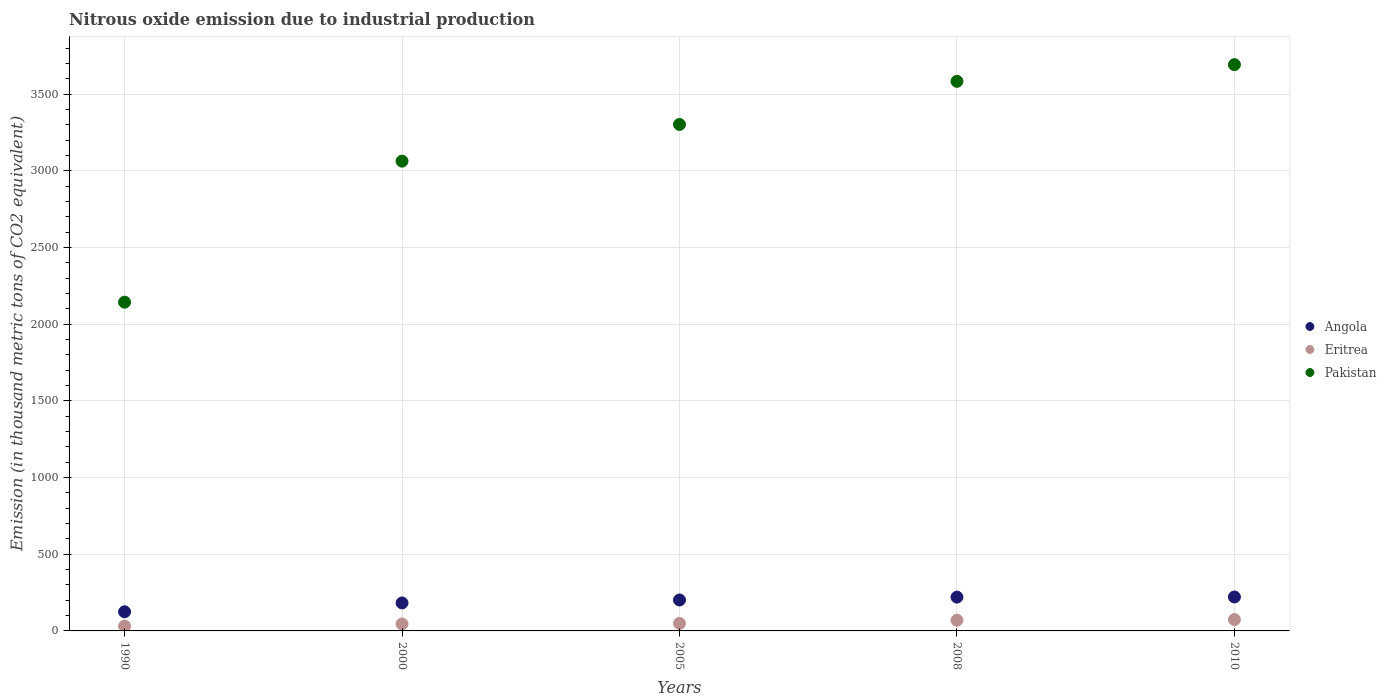What is the amount of nitrous oxide emitted in Angola in 2005?
Provide a short and direct response. 201.8. Across all years, what is the maximum amount of nitrous oxide emitted in Angola?
Provide a short and direct response. 221.4. Across all years, what is the minimum amount of nitrous oxide emitted in Eritrea?
Your answer should be very brief. 31.3. In which year was the amount of nitrous oxide emitted in Angola maximum?
Ensure brevity in your answer.  2010. In which year was the amount of nitrous oxide emitted in Pakistan minimum?
Your answer should be very brief. 1990. What is the total amount of nitrous oxide emitted in Eritrea in the graph?
Keep it short and to the point. 269.4. What is the difference between the amount of nitrous oxide emitted in Pakistan in 2000 and that in 2010?
Your answer should be very brief. -629.3. What is the difference between the amount of nitrous oxide emitted in Eritrea in 2005 and the amount of nitrous oxide emitted in Angola in 2010?
Ensure brevity in your answer.  -172.3. What is the average amount of nitrous oxide emitted in Pakistan per year?
Make the answer very short. 3157.4. In the year 2000, what is the difference between the amount of nitrous oxide emitted in Eritrea and amount of nitrous oxide emitted in Angola?
Your answer should be very brief. -137.1. In how many years, is the amount of nitrous oxide emitted in Pakistan greater than 2300 thousand metric tons?
Your answer should be very brief. 4. What is the ratio of the amount of nitrous oxide emitted in Eritrea in 1990 to that in 2008?
Provide a succinct answer. 0.45. Is the difference between the amount of nitrous oxide emitted in Eritrea in 1990 and 2008 greater than the difference between the amount of nitrous oxide emitted in Angola in 1990 and 2008?
Give a very brief answer. Yes. What is the difference between the highest and the second highest amount of nitrous oxide emitted in Pakistan?
Make the answer very short. 108.8. What is the difference between the highest and the lowest amount of nitrous oxide emitted in Eritrea?
Make the answer very short. 42.6. Is the sum of the amount of nitrous oxide emitted in Eritrea in 2000 and 2008 greater than the maximum amount of nitrous oxide emitted in Angola across all years?
Ensure brevity in your answer.  No. Is the amount of nitrous oxide emitted in Eritrea strictly greater than the amount of nitrous oxide emitted in Angola over the years?
Your answer should be compact. No. How many dotlines are there?
Your answer should be very brief. 3. Does the graph contain grids?
Keep it short and to the point. Yes. How many legend labels are there?
Your response must be concise. 3. How are the legend labels stacked?
Provide a short and direct response. Vertical. What is the title of the graph?
Offer a terse response. Nitrous oxide emission due to industrial production. What is the label or title of the Y-axis?
Provide a succinct answer. Emission (in thousand metric tons of CO2 equivalent). What is the Emission (in thousand metric tons of CO2 equivalent) in Angola in 1990?
Make the answer very short. 124.8. What is the Emission (in thousand metric tons of CO2 equivalent) in Eritrea in 1990?
Keep it short and to the point. 31.3. What is the Emission (in thousand metric tons of CO2 equivalent) in Pakistan in 1990?
Offer a terse response. 2143.8. What is the Emission (in thousand metric tons of CO2 equivalent) in Angola in 2000?
Ensure brevity in your answer.  182.5. What is the Emission (in thousand metric tons of CO2 equivalent) of Eritrea in 2000?
Keep it short and to the point. 45.4. What is the Emission (in thousand metric tons of CO2 equivalent) in Pakistan in 2000?
Your answer should be very brief. 3063.5. What is the Emission (in thousand metric tons of CO2 equivalent) in Angola in 2005?
Your answer should be compact. 201.8. What is the Emission (in thousand metric tons of CO2 equivalent) of Eritrea in 2005?
Give a very brief answer. 49.1. What is the Emission (in thousand metric tons of CO2 equivalent) in Pakistan in 2005?
Provide a succinct answer. 3302.9. What is the Emission (in thousand metric tons of CO2 equivalent) of Angola in 2008?
Keep it short and to the point. 220.4. What is the Emission (in thousand metric tons of CO2 equivalent) of Eritrea in 2008?
Provide a short and direct response. 69.7. What is the Emission (in thousand metric tons of CO2 equivalent) in Pakistan in 2008?
Your answer should be very brief. 3584. What is the Emission (in thousand metric tons of CO2 equivalent) of Angola in 2010?
Your answer should be very brief. 221.4. What is the Emission (in thousand metric tons of CO2 equivalent) in Eritrea in 2010?
Offer a very short reply. 73.9. What is the Emission (in thousand metric tons of CO2 equivalent) in Pakistan in 2010?
Provide a short and direct response. 3692.8. Across all years, what is the maximum Emission (in thousand metric tons of CO2 equivalent) in Angola?
Provide a short and direct response. 221.4. Across all years, what is the maximum Emission (in thousand metric tons of CO2 equivalent) of Eritrea?
Provide a short and direct response. 73.9. Across all years, what is the maximum Emission (in thousand metric tons of CO2 equivalent) of Pakistan?
Keep it short and to the point. 3692.8. Across all years, what is the minimum Emission (in thousand metric tons of CO2 equivalent) in Angola?
Give a very brief answer. 124.8. Across all years, what is the minimum Emission (in thousand metric tons of CO2 equivalent) in Eritrea?
Your answer should be compact. 31.3. Across all years, what is the minimum Emission (in thousand metric tons of CO2 equivalent) in Pakistan?
Ensure brevity in your answer.  2143.8. What is the total Emission (in thousand metric tons of CO2 equivalent) of Angola in the graph?
Your answer should be compact. 950.9. What is the total Emission (in thousand metric tons of CO2 equivalent) in Eritrea in the graph?
Keep it short and to the point. 269.4. What is the total Emission (in thousand metric tons of CO2 equivalent) of Pakistan in the graph?
Your answer should be very brief. 1.58e+04. What is the difference between the Emission (in thousand metric tons of CO2 equivalent) in Angola in 1990 and that in 2000?
Provide a succinct answer. -57.7. What is the difference between the Emission (in thousand metric tons of CO2 equivalent) of Eritrea in 1990 and that in 2000?
Give a very brief answer. -14.1. What is the difference between the Emission (in thousand metric tons of CO2 equivalent) in Pakistan in 1990 and that in 2000?
Provide a short and direct response. -919.7. What is the difference between the Emission (in thousand metric tons of CO2 equivalent) of Angola in 1990 and that in 2005?
Make the answer very short. -77. What is the difference between the Emission (in thousand metric tons of CO2 equivalent) of Eritrea in 1990 and that in 2005?
Offer a very short reply. -17.8. What is the difference between the Emission (in thousand metric tons of CO2 equivalent) in Pakistan in 1990 and that in 2005?
Make the answer very short. -1159.1. What is the difference between the Emission (in thousand metric tons of CO2 equivalent) in Angola in 1990 and that in 2008?
Provide a succinct answer. -95.6. What is the difference between the Emission (in thousand metric tons of CO2 equivalent) of Eritrea in 1990 and that in 2008?
Offer a terse response. -38.4. What is the difference between the Emission (in thousand metric tons of CO2 equivalent) of Pakistan in 1990 and that in 2008?
Your answer should be very brief. -1440.2. What is the difference between the Emission (in thousand metric tons of CO2 equivalent) in Angola in 1990 and that in 2010?
Your response must be concise. -96.6. What is the difference between the Emission (in thousand metric tons of CO2 equivalent) of Eritrea in 1990 and that in 2010?
Make the answer very short. -42.6. What is the difference between the Emission (in thousand metric tons of CO2 equivalent) of Pakistan in 1990 and that in 2010?
Make the answer very short. -1549. What is the difference between the Emission (in thousand metric tons of CO2 equivalent) of Angola in 2000 and that in 2005?
Make the answer very short. -19.3. What is the difference between the Emission (in thousand metric tons of CO2 equivalent) of Eritrea in 2000 and that in 2005?
Provide a short and direct response. -3.7. What is the difference between the Emission (in thousand metric tons of CO2 equivalent) of Pakistan in 2000 and that in 2005?
Keep it short and to the point. -239.4. What is the difference between the Emission (in thousand metric tons of CO2 equivalent) of Angola in 2000 and that in 2008?
Ensure brevity in your answer.  -37.9. What is the difference between the Emission (in thousand metric tons of CO2 equivalent) of Eritrea in 2000 and that in 2008?
Ensure brevity in your answer.  -24.3. What is the difference between the Emission (in thousand metric tons of CO2 equivalent) of Pakistan in 2000 and that in 2008?
Keep it short and to the point. -520.5. What is the difference between the Emission (in thousand metric tons of CO2 equivalent) in Angola in 2000 and that in 2010?
Your response must be concise. -38.9. What is the difference between the Emission (in thousand metric tons of CO2 equivalent) of Eritrea in 2000 and that in 2010?
Provide a short and direct response. -28.5. What is the difference between the Emission (in thousand metric tons of CO2 equivalent) in Pakistan in 2000 and that in 2010?
Make the answer very short. -629.3. What is the difference between the Emission (in thousand metric tons of CO2 equivalent) of Angola in 2005 and that in 2008?
Give a very brief answer. -18.6. What is the difference between the Emission (in thousand metric tons of CO2 equivalent) of Eritrea in 2005 and that in 2008?
Ensure brevity in your answer.  -20.6. What is the difference between the Emission (in thousand metric tons of CO2 equivalent) in Pakistan in 2005 and that in 2008?
Ensure brevity in your answer.  -281.1. What is the difference between the Emission (in thousand metric tons of CO2 equivalent) in Angola in 2005 and that in 2010?
Offer a terse response. -19.6. What is the difference between the Emission (in thousand metric tons of CO2 equivalent) of Eritrea in 2005 and that in 2010?
Offer a very short reply. -24.8. What is the difference between the Emission (in thousand metric tons of CO2 equivalent) of Pakistan in 2005 and that in 2010?
Offer a very short reply. -389.9. What is the difference between the Emission (in thousand metric tons of CO2 equivalent) in Pakistan in 2008 and that in 2010?
Your response must be concise. -108.8. What is the difference between the Emission (in thousand metric tons of CO2 equivalent) of Angola in 1990 and the Emission (in thousand metric tons of CO2 equivalent) of Eritrea in 2000?
Give a very brief answer. 79.4. What is the difference between the Emission (in thousand metric tons of CO2 equivalent) of Angola in 1990 and the Emission (in thousand metric tons of CO2 equivalent) of Pakistan in 2000?
Give a very brief answer. -2938.7. What is the difference between the Emission (in thousand metric tons of CO2 equivalent) in Eritrea in 1990 and the Emission (in thousand metric tons of CO2 equivalent) in Pakistan in 2000?
Give a very brief answer. -3032.2. What is the difference between the Emission (in thousand metric tons of CO2 equivalent) in Angola in 1990 and the Emission (in thousand metric tons of CO2 equivalent) in Eritrea in 2005?
Offer a very short reply. 75.7. What is the difference between the Emission (in thousand metric tons of CO2 equivalent) in Angola in 1990 and the Emission (in thousand metric tons of CO2 equivalent) in Pakistan in 2005?
Your response must be concise. -3178.1. What is the difference between the Emission (in thousand metric tons of CO2 equivalent) of Eritrea in 1990 and the Emission (in thousand metric tons of CO2 equivalent) of Pakistan in 2005?
Offer a terse response. -3271.6. What is the difference between the Emission (in thousand metric tons of CO2 equivalent) in Angola in 1990 and the Emission (in thousand metric tons of CO2 equivalent) in Eritrea in 2008?
Make the answer very short. 55.1. What is the difference between the Emission (in thousand metric tons of CO2 equivalent) of Angola in 1990 and the Emission (in thousand metric tons of CO2 equivalent) of Pakistan in 2008?
Keep it short and to the point. -3459.2. What is the difference between the Emission (in thousand metric tons of CO2 equivalent) of Eritrea in 1990 and the Emission (in thousand metric tons of CO2 equivalent) of Pakistan in 2008?
Give a very brief answer. -3552.7. What is the difference between the Emission (in thousand metric tons of CO2 equivalent) in Angola in 1990 and the Emission (in thousand metric tons of CO2 equivalent) in Eritrea in 2010?
Your response must be concise. 50.9. What is the difference between the Emission (in thousand metric tons of CO2 equivalent) in Angola in 1990 and the Emission (in thousand metric tons of CO2 equivalent) in Pakistan in 2010?
Make the answer very short. -3568. What is the difference between the Emission (in thousand metric tons of CO2 equivalent) of Eritrea in 1990 and the Emission (in thousand metric tons of CO2 equivalent) of Pakistan in 2010?
Your answer should be compact. -3661.5. What is the difference between the Emission (in thousand metric tons of CO2 equivalent) in Angola in 2000 and the Emission (in thousand metric tons of CO2 equivalent) in Eritrea in 2005?
Keep it short and to the point. 133.4. What is the difference between the Emission (in thousand metric tons of CO2 equivalent) in Angola in 2000 and the Emission (in thousand metric tons of CO2 equivalent) in Pakistan in 2005?
Your answer should be compact. -3120.4. What is the difference between the Emission (in thousand metric tons of CO2 equivalent) of Eritrea in 2000 and the Emission (in thousand metric tons of CO2 equivalent) of Pakistan in 2005?
Give a very brief answer. -3257.5. What is the difference between the Emission (in thousand metric tons of CO2 equivalent) of Angola in 2000 and the Emission (in thousand metric tons of CO2 equivalent) of Eritrea in 2008?
Your response must be concise. 112.8. What is the difference between the Emission (in thousand metric tons of CO2 equivalent) of Angola in 2000 and the Emission (in thousand metric tons of CO2 equivalent) of Pakistan in 2008?
Provide a succinct answer. -3401.5. What is the difference between the Emission (in thousand metric tons of CO2 equivalent) of Eritrea in 2000 and the Emission (in thousand metric tons of CO2 equivalent) of Pakistan in 2008?
Your answer should be compact. -3538.6. What is the difference between the Emission (in thousand metric tons of CO2 equivalent) of Angola in 2000 and the Emission (in thousand metric tons of CO2 equivalent) of Eritrea in 2010?
Give a very brief answer. 108.6. What is the difference between the Emission (in thousand metric tons of CO2 equivalent) in Angola in 2000 and the Emission (in thousand metric tons of CO2 equivalent) in Pakistan in 2010?
Provide a short and direct response. -3510.3. What is the difference between the Emission (in thousand metric tons of CO2 equivalent) of Eritrea in 2000 and the Emission (in thousand metric tons of CO2 equivalent) of Pakistan in 2010?
Keep it short and to the point. -3647.4. What is the difference between the Emission (in thousand metric tons of CO2 equivalent) of Angola in 2005 and the Emission (in thousand metric tons of CO2 equivalent) of Eritrea in 2008?
Provide a short and direct response. 132.1. What is the difference between the Emission (in thousand metric tons of CO2 equivalent) of Angola in 2005 and the Emission (in thousand metric tons of CO2 equivalent) of Pakistan in 2008?
Keep it short and to the point. -3382.2. What is the difference between the Emission (in thousand metric tons of CO2 equivalent) in Eritrea in 2005 and the Emission (in thousand metric tons of CO2 equivalent) in Pakistan in 2008?
Your response must be concise. -3534.9. What is the difference between the Emission (in thousand metric tons of CO2 equivalent) of Angola in 2005 and the Emission (in thousand metric tons of CO2 equivalent) of Eritrea in 2010?
Provide a succinct answer. 127.9. What is the difference between the Emission (in thousand metric tons of CO2 equivalent) of Angola in 2005 and the Emission (in thousand metric tons of CO2 equivalent) of Pakistan in 2010?
Make the answer very short. -3491. What is the difference between the Emission (in thousand metric tons of CO2 equivalent) in Eritrea in 2005 and the Emission (in thousand metric tons of CO2 equivalent) in Pakistan in 2010?
Your response must be concise. -3643.7. What is the difference between the Emission (in thousand metric tons of CO2 equivalent) of Angola in 2008 and the Emission (in thousand metric tons of CO2 equivalent) of Eritrea in 2010?
Offer a very short reply. 146.5. What is the difference between the Emission (in thousand metric tons of CO2 equivalent) of Angola in 2008 and the Emission (in thousand metric tons of CO2 equivalent) of Pakistan in 2010?
Your answer should be compact. -3472.4. What is the difference between the Emission (in thousand metric tons of CO2 equivalent) of Eritrea in 2008 and the Emission (in thousand metric tons of CO2 equivalent) of Pakistan in 2010?
Give a very brief answer. -3623.1. What is the average Emission (in thousand metric tons of CO2 equivalent) in Angola per year?
Keep it short and to the point. 190.18. What is the average Emission (in thousand metric tons of CO2 equivalent) of Eritrea per year?
Ensure brevity in your answer.  53.88. What is the average Emission (in thousand metric tons of CO2 equivalent) in Pakistan per year?
Ensure brevity in your answer.  3157.4. In the year 1990, what is the difference between the Emission (in thousand metric tons of CO2 equivalent) in Angola and Emission (in thousand metric tons of CO2 equivalent) in Eritrea?
Your answer should be compact. 93.5. In the year 1990, what is the difference between the Emission (in thousand metric tons of CO2 equivalent) in Angola and Emission (in thousand metric tons of CO2 equivalent) in Pakistan?
Offer a very short reply. -2019. In the year 1990, what is the difference between the Emission (in thousand metric tons of CO2 equivalent) in Eritrea and Emission (in thousand metric tons of CO2 equivalent) in Pakistan?
Provide a succinct answer. -2112.5. In the year 2000, what is the difference between the Emission (in thousand metric tons of CO2 equivalent) in Angola and Emission (in thousand metric tons of CO2 equivalent) in Eritrea?
Keep it short and to the point. 137.1. In the year 2000, what is the difference between the Emission (in thousand metric tons of CO2 equivalent) of Angola and Emission (in thousand metric tons of CO2 equivalent) of Pakistan?
Provide a short and direct response. -2881. In the year 2000, what is the difference between the Emission (in thousand metric tons of CO2 equivalent) of Eritrea and Emission (in thousand metric tons of CO2 equivalent) of Pakistan?
Keep it short and to the point. -3018.1. In the year 2005, what is the difference between the Emission (in thousand metric tons of CO2 equivalent) of Angola and Emission (in thousand metric tons of CO2 equivalent) of Eritrea?
Give a very brief answer. 152.7. In the year 2005, what is the difference between the Emission (in thousand metric tons of CO2 equivalent) in Angola and Emission (in thousand metric tons of CO2 equivalent) in Pakistan?
Ensure brevity in your answer.  -3101.1. In the year 2005, what is the difference between the Emission (in thousand metric tons of CO2 equivalent) in Eritrea and Emission (in thousand metric tons of CO2 equivalent) in Pakistan?
Provide a succinct answer. -3253.8. In the year 2008, what is the difference between the Emission (in thousand metric tons of CO2 equivalent) in Angola and Emission (in thousand metric tons of CO2 equivalent) in Eritrea?
Ensure brevity in your answer.  150.7. In the year 2008, what is the difference between the Emission (in thousand metric tons of CO2 equivalent) of Angola and Emission (in thousand metric tons of CO2 equivalent) of Pakistan?
Offer a very short reply. -3363.6. In the year 2008, what is the difference between the Emission (in thousand metric tons of CO2 equivalent) in Eritrea and Emission (in thousand metric tons of CO2 equivalent) in Pakistan?
Provide a succinct answer. -3514.3. In the year 2010, what is the difference between the Emission (in thousand metric tons of CO2 equivalent) of Angola and Emission (in thousand metric tons of CO2 equivalent) of Eritrea?
Your response must be concise. 147.5. In the year 2010, what is the difference between the Emission (in thousand metric tons of CO2 equivalent) of Angola and Emission (in thousand metric tons of CO2 equivalent) of Pakistan?
Your answer should be very brief. -3471.4. In the year 2010, what is the difference between the Emission (in thousand metric tons of CO2 equivalent) of Eritrea and Emission (in thousand metric tons of CO2 equivalent) of Pakistan?
Offer a terse response. -3618.9. What is the ratio of the Emission (in thousand metric tons of CO2 equivalent) of Angola in 1990 to that in 2000?
Your answer should be very brief. 0.68. What is the ratio of the Emission (in thousand metric tons of CO2 equivalent) in Eritrea in 1990 to that in 2000?
Provide a short and direct response. 0.69. What is the ratio of the Emission (in thousand metric tons of CO2 equivalent) in Pakistan in 1990 to that in 2000?
Provide a succinct answer. 0.7. What is the ratio of the Emission (in thousand metric tons of CO2 equivalent) of Angola in 1990 to that in 2005?
Your answer should be compact. 0.62. What is the ratio of the Emission (in thousand metric tons of CO2 equivalent) of Eritrea in 1990 to that in 2005?
Ensure brevity in your answer.  0.64. What is the ratio of the Emission (in thousand metric tons of CO2 equivalent) of Pakistan in 1990 to that in 2005?
Your response must be concise. 0.65. What is the ratio of the Emission (in thousand metric tons of CO2 equivalent) of Angola in 1990 to that in 2008?
Ensure brevity in your answer.  0.57. What is the ratio of the Emission (in thousand metric tons of CO2 equivalent) in Eritrea in 1990 to that in 2008?
Provide a short and direct response. 0.45. What is the ratio of the Emission (in thousand metric tons of CO2 equivalent) of Pakistan in 1990 to that in 2008?
Ensure brevity in your answer.  0.6. What is the ratio of the Emission (in thousand metric tons of CO2 equivalent) of Angola in 1990 to that in 2010?
Offer a very short reply. 0.56. What is the ratio of the Emission (in thousand metric tons of CO2 equivalent) of Eritrea in 1990 to that in 2010?
Offer a very short reply. 0.42. What is the ratio of the Emission (in thousand metric tons of CO2 equivalent) of Pakistan in 1990 to that in 2010?
Your answer should be compact. 0.58. What is the ratio of the Emission (in thousand metric tons of CO2 equivalent) of Angola in 2000 to that in 2005?
Make the answer very short. 0.9. What is the ratio of the Emission (in thousand metric tons of CO2 equivalent) of Eritrea in 2000 to that in 2005?
Provide a succinct answer. 0.92. What is the ratio of the Emission (in thousand metric tons of CO2 equivalent) in Pakistan in 2000 to that in 2005?
Keep it short and to the point. 0.93. What is the ratio of the Emission (in thousand metric tons of CO2 equivalent) in Angola in 2000 to that in 2008?
Offer a terse response. 0.83. What is the ratio of the Emission (in thousand metric tons of CO2 equivalent) of Eritrea in 2000 to that in 2008?
Your response must be concise. 0.65. What is the ratio of the Emission (in thousand metric tons of CO2 equivalent) of Pakistan in 2000 to that in 2008?
Provide a short and direct response. 0.85. What is the ratio of the Emission (in thousand metric tons of CO2 equivalent) in Angola in 2000 to that in 2010?
Give a very brief answer. 0.82. What is the ratio of the Emission (in thousand metric tons of CO2 equivalent) of Eritrea in 2000 to that in 2010?
Provide a short and direct response. 0.61. What is the ratio of the Emission (in thousand metric tons of CO2 equivalent) of Pakistan in 2000 to that in 2010?
Keep it short and to the point. 0.83. What is the ratio of the Emission (in thousand metric tons of CO2 equivalent) in Angola in 2005 to that in 2008?
Make the answer very short. 0.92. What is the ratio of the Emission (in thousand metric tons of CO2 equivalent) of Eritrea in 2005 to that in 2008?
Keep it short and to the point. 0.7. What is the ratio of the Emission (in thousand metric tons of CO2 equivalent) of Pakistan in 2005 to that in 2008?
Offer a terse response. 0.92. What is the ratio of the Emission (in thousand metric tons of CO2 equivalent) in Angola in 2005 to that in 2010?
Make the answer very short. 0.91. What is the ratio of the Emission (in thousand metric tons of CO2 equivalent) of Eritrea in 2005 to that in 2010?
Your answer should be compact. 0.66. What is the ratio of the Emission (in thousand metric tons of CO2 equivalent) in Pakistan in 2005 to that in 2010?
Ensure brevity in your answer.  0.89. What is the ratio of the Emission (in thousand metric tons of CO2 equivalent) in Angola in 2008 to that in 2010?
Give a very brief answer. 1. What is the ratio of the Emission (in thousand metric tons of CO2 equivalent) in Eritrea in 2008 to that in 2010?
Offer a terse response. 0.94. What is the ratio of the Emission (in thousand metric tons of CO2 equivalent) in Pakistan in 2008 to that in 2010?
Make the answer very short. 0.97. What is the difference between the highest and the second highest Emission (in thousand metric tons of CO2 equivalent) in Angola?
Offer a terse response. 1. What is the difference between the highest and the second highest Emission (in thousand metric tons of CO2 equivalent) of Eritrea?
Offer a terse response. 4.2. What is the difference between the highest and the second highest Emission (in thousand metric tons of CO2 equivalent) in Pakistan?
Ensure brevity in your answer.  108.8. What is the difference between the highest and the lowest Emission (in thousand metric tons of CO2 equivalent) in Angola?
Your answer should be very brief. 96.6. What is the difference between the highest and the lowest Emission (in thousand metric tons of CO2 equivalent) of Eritrea?
Give a very brief answer. 42.6. What is the difference between the highest and the lowest Emission (in thousand metric tons of CO2 equivalent) of Pakistan?
Your response must be concise. 1549. 